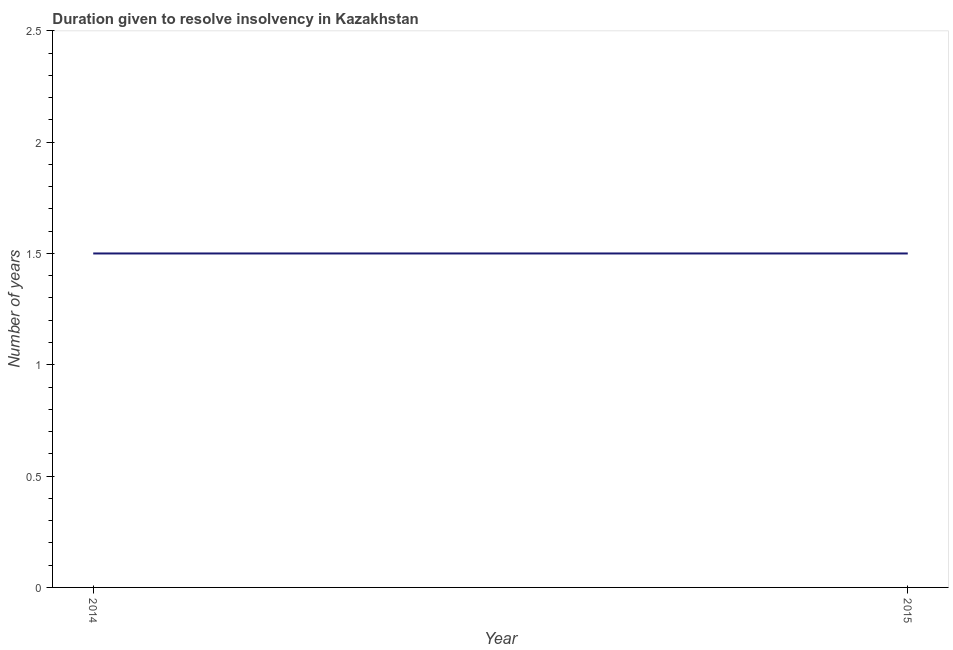What is the number of years to resolve insolvency in 2015?
Give a very brief answer. 1.5. Across all years, what is the maximum number of years to resolve insolvency?
Offer a very short reply. 1.5. Across all years, what is the minimum number of years to resolve insolvency?
Provide a short and direct response. 1.5. In which year was the number of years to resolve insolvency minimum?
Keep it short and to the point. 2014. What is the average number of years to resolve insolvency per year?
Make the answer very short. 1.5. What is the median number of years to resolve insolvency?
Give a very brief answer. 1.5. In how many years, is the number of years to resolve insolvency greater than 1 ?
Offer a very short reply. 2. Do a majority of the years between 2015 and 2014 (inclusive) have number of years to resolve insolvency greater than 2.4 ?
Your answer should be compact. No. What is the ratio of the number of years to resolve insolvency in 2014 to that in 2015?
Offer a terse response. 1. Is the number of years to resolve insolvency in 2014 less than that in 2015?
Your answer should be very brief. No. Does the number of years to resolve insolvency monotonically increase over the years?
Provide a succinct answer. No. Are the values on the major ticks of Y-axis written in scientific E-notation?
Make the answer very short. No. Does the graph contain any zero values?
Your answer should be compact. No. Does the graph contain grids?
Provide a succinct answer. No. What is the title of the graph?
Provide a succinct answer. Duration given to resolve insolvency in Kazakhstan. What is the label or title of the X-axis?
Offer a very short reply. Year. What is the label or title of the Y-axis?
Give a very brief answer. Number of years. What is the difference between the Number of years in 2014 and 2015?
Keep it short and to the point. 0. 